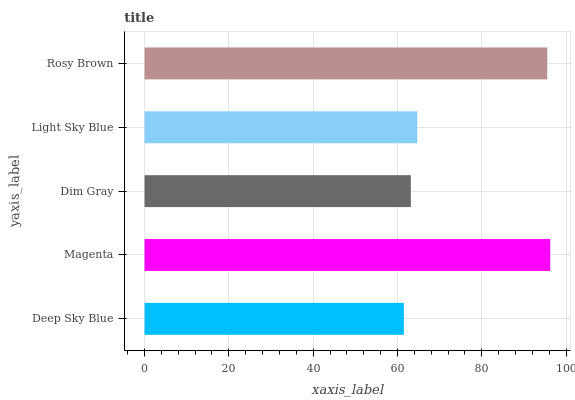Is Deep Sky Blue the minimum?
Answer yes or no. Yes. Is Magenta the maximum?
Answer yes or no. Yes. Is Dim Gray the minimum?
Answer yes or no. No. Is Dim Gray the maximum?
Answer yes or no. No. Is Magenta greater than Dim Gray?
Answer yes or no. Yes. Is Dim Gray less than Magenta?
Answer yes or no. Yes. Is Dim Gray greater than Magenta?
Answer yes or no. No. Is Magenta less than Dim Gray?
Answer yes or no. No. Is Light Sky Blue the high median?
Answer yes or no. Yes. Is Light Sky Blue the low median?
Answer yes or no. Yes. Is Magenta the high median?
Answer yes or no. No. Is Magenta the low median?
Answer yes or no. No. 